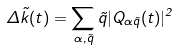<formula> <loc_0><loc_0><loc_500><loc_500>\Delta { \vec { k } } ( t ) = \sum _ { \alpha , \vec { q } } { \vec { q } } | Q _ { \alpha \vec { q } } ( t ) | ^ { 2 }</formula> 